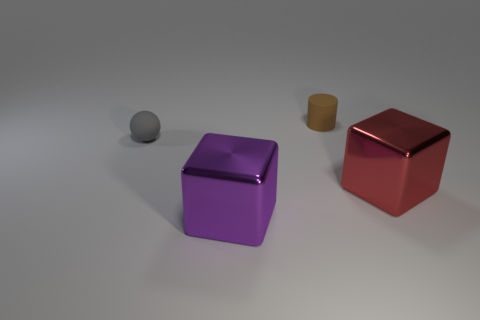Are the objects arranged in any particular pattern? The objects appear to be placed at random, without a discernible pattern. They are spaced out on a flat surface, each object standing alone. 